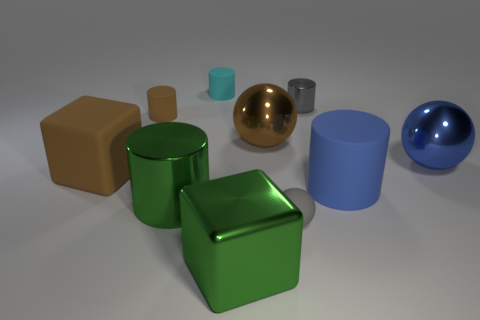Is the number of cyan matte things that are right of the gray metal cylinder greater than the number of blue cylinders?
Offer a terse response. No. There is a tiny gray thing that is in front of the big sphere that is to the left of the metal cylinder that is on the right side of the large metal block; what is its shape?
Make the answer very short. Sphere. There is a rubber object on the right side of the gray cylinder; does it have the same shape as the gray object on the left side of the small gray cylinder?
Provide a short and direct response. No. Are there any other things that have the same size as the blue rubber object?
Provide a short and direct response. Yes. What number of cylinders are large rubber things or small rubber things?
Make the answer very short. 3. Does the brown cylinder have the same material as the blue ball?
Keep it short and to the point. No. What number of other things are the same color as the small metal thing?
Provide a succinct answer. 1. What shape is the green metallic thing in front of the rubber ball?
Offer a very short reply. Cube. What number of objects are tiny shiny objects or green metal cylinders?
Ensure brevity in your answer.  2. There is a blue metallic object; is it the same size as the metallic cylinder that is behind the big blue metallic sphere?
Your response must be concise. No. 